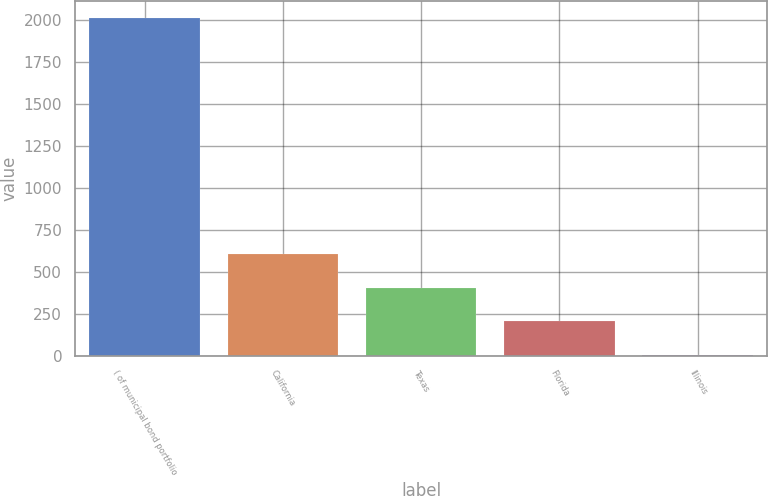<chart> <loc_0><loc_0><loc_500><loc_500><bar_chart><fcel>( of municipal bond portfolio<fcel>California<fcel>Texas<fcel>Florida<fcel>Illinois<nl><fcel>2008<fcel>605.69<fcel>405.36<fcel>205.03<fcel>4.7<nl></chart> 